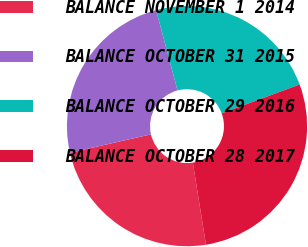Convert chart. <chart><loc_0><loc_0><loc_500><loc_500><pie_chart><fcel>BALANCE NOVEMBER 1 2014<fcel>BALANCE OCTOBER 31 2015<fcel>BALANCE OCTOBER 29 2016<fcel>BALANCE OCTOBER 28 2017<nl><fcel>23.96%<fcel>24.42%<fcel>23.5%<fcel>28.11%<nl></chart> 